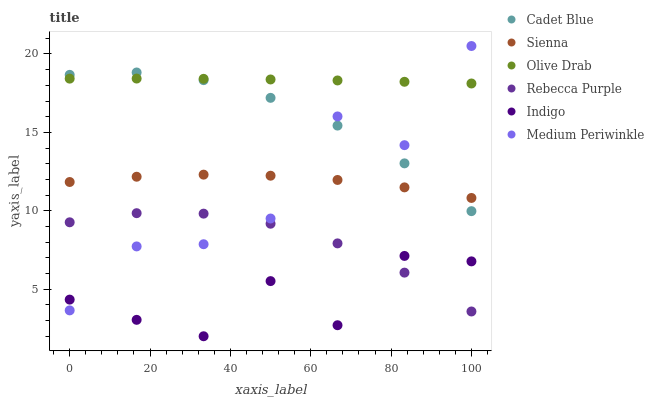Does Indigo have the minimum area under the curve?
Answer yes or no. Yes. Does Olive Drab have the maximum area under the curve?
Answer yes or no. Yes. Does Medium Periwinkle have the minimum area under the curve?
Answer yes or no. No. Does Medium Periwinkle have the maximum area under the curve?
Answer yes or no. No. Is Olive Drab the smoothest?
Answer yes or no. Yes. Is Medium Periwinkle the roughest?
Answer yes or no. Yes. Is Indigo the smoothest?
Answer yes or no. No. Is Indigo the roughest?
Answer yes or no. No. Does Indigo have the lowest value?
Answer yes or no. Yes. Does Medium Periwinkle have the lowest value?
Answer yes or no. No. Does Medium Periwinkle have the highest value?
Answer yes or no. Yes. Does Indigo have the highest value?
Answer yes or no. No. Is Rebecca Purple less than Sienna?
Answer yes or no. Yes. Is Olive Drab greater than Indigo?
Answer yes or no. Yes. Does Sienna intersect Medium Periwinkle?
Answer yes or no. Yes. Is Sienna less than Medium Periwinkle?
Answer yes or no. No. Is Sienna greater than Medium Periwinkle?
Answer yes or no. No. Does Rebecca Purple intersect Sienna?
Answer yes or no. No. 